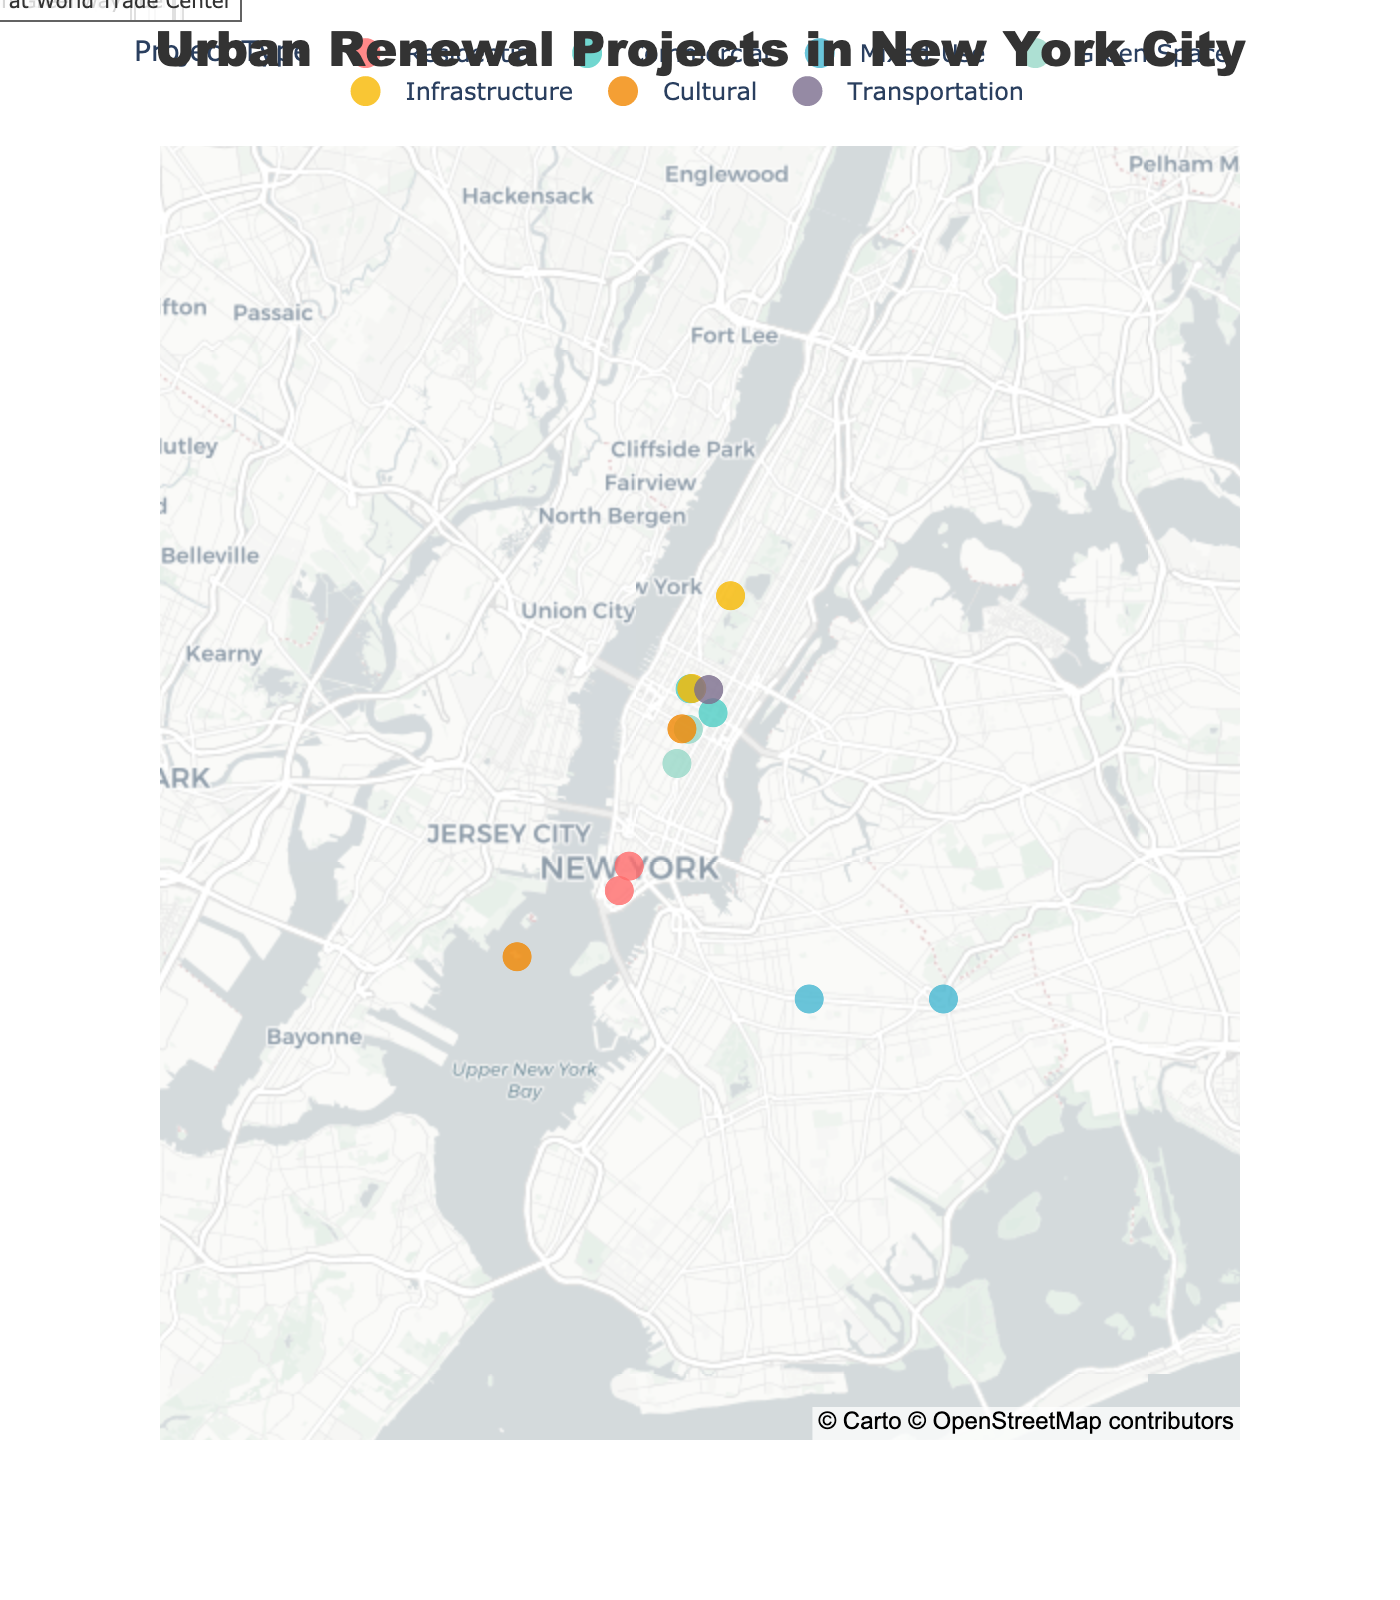Which project type has the most locations? By visually inspecting the color distribution on the map and identifying the most frequent color, one can determine the project type with the most locations
Answer: Mixed-Use What is the latitude and longitude of the Hudson Yards Redevelopment project? Locate the 'Hudson Yards Redevelopment' annotation on the map and read the latitude and longitude coordinates directly from the figure.
Answer: 40.7128, -74.0060 Are there more Commercial or Residential projects? Count the number of markers color-coded for Commercial (turquoise) and Residential (red) and compare the counts.
Answer: Commercial What is the average latitude of the Mixed-Use projects? Identify the Mixed-Use projects (Downtown Brooklyn Revitalization and Jamaica Now Action Plan) and calculate their average latitude: (40.6782 + 40.6782) / 2
Answer: 40.6782 Which project is located at 40.7484 latitude and -73.9857 longitude? Find the point on the map with these coordinates and read the associated project name.
Answer: East River Waterfront Esplanade Is there a project closer to the East River Waterfront Esplanade or the Performing Arts Center at World Trade Center? Identify both locations on the map and observe which project (potentially Battery Park City Expansion) is geographically closer to either project.
Answer: Battery Park City Expansion How many different types of projects are there altogether? Count the number of unique colors used to mark the different project types on the map.
Answer: 7 Which area of New York City has the highest concentration of Green Space projects? Look for the areas with a high concentration of markers colored green on the map to identify the location.
Answer: Midtown Manhattan Which project is situated to the east of the Second Avenue Subway Extension? Compare the longitude values and identify the project with a larger longitude value than Second Avenue Subway Extension's -73.9712
Answer: Midtown East Rezoning What is the difference in longitude between the Governors Island Transformation and the Penn Station Redevelopment? Subtract the longitude of Governors Island Transformation (-74.0445) from the longitude of Penn Station Redevelopment (-73.9787): -73.9787 - (-74.0445)
Answer: 0.0658 